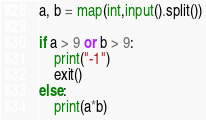Convert code to text. <code><loc_0><loc_0><loc_500><loc_500><_Python_>a, b = map(int,input().split())

if a > 9 or b > 9:
    print("-1")
    exit()
else:
    print(a*b)</code> 